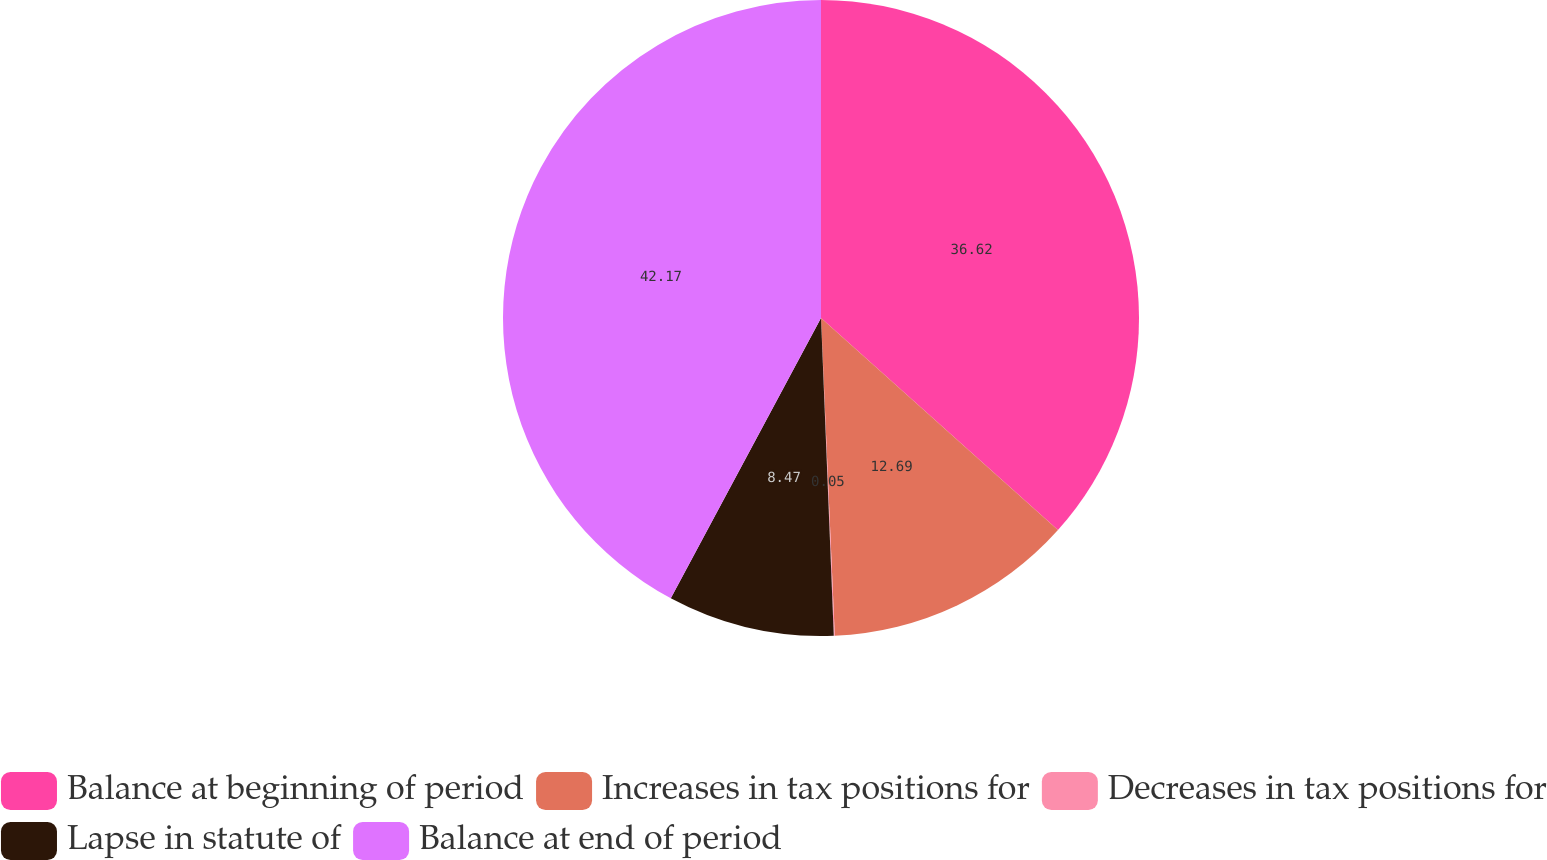Convert chart. <chart><loc_0><loc_0><loc_500><loc_500><pie_chart><fcel>Balance at beginning of period<fcel>Increases in tax positions for<fcel>Decreases in tax positions for<fcel>Lapse in statute of<fcel>Balance at end of period<nl><fcel>36.62%<fcel>12.69%<fcel>0.05%<fcel>8.47%<fcel>42.17%<nl></chart> 